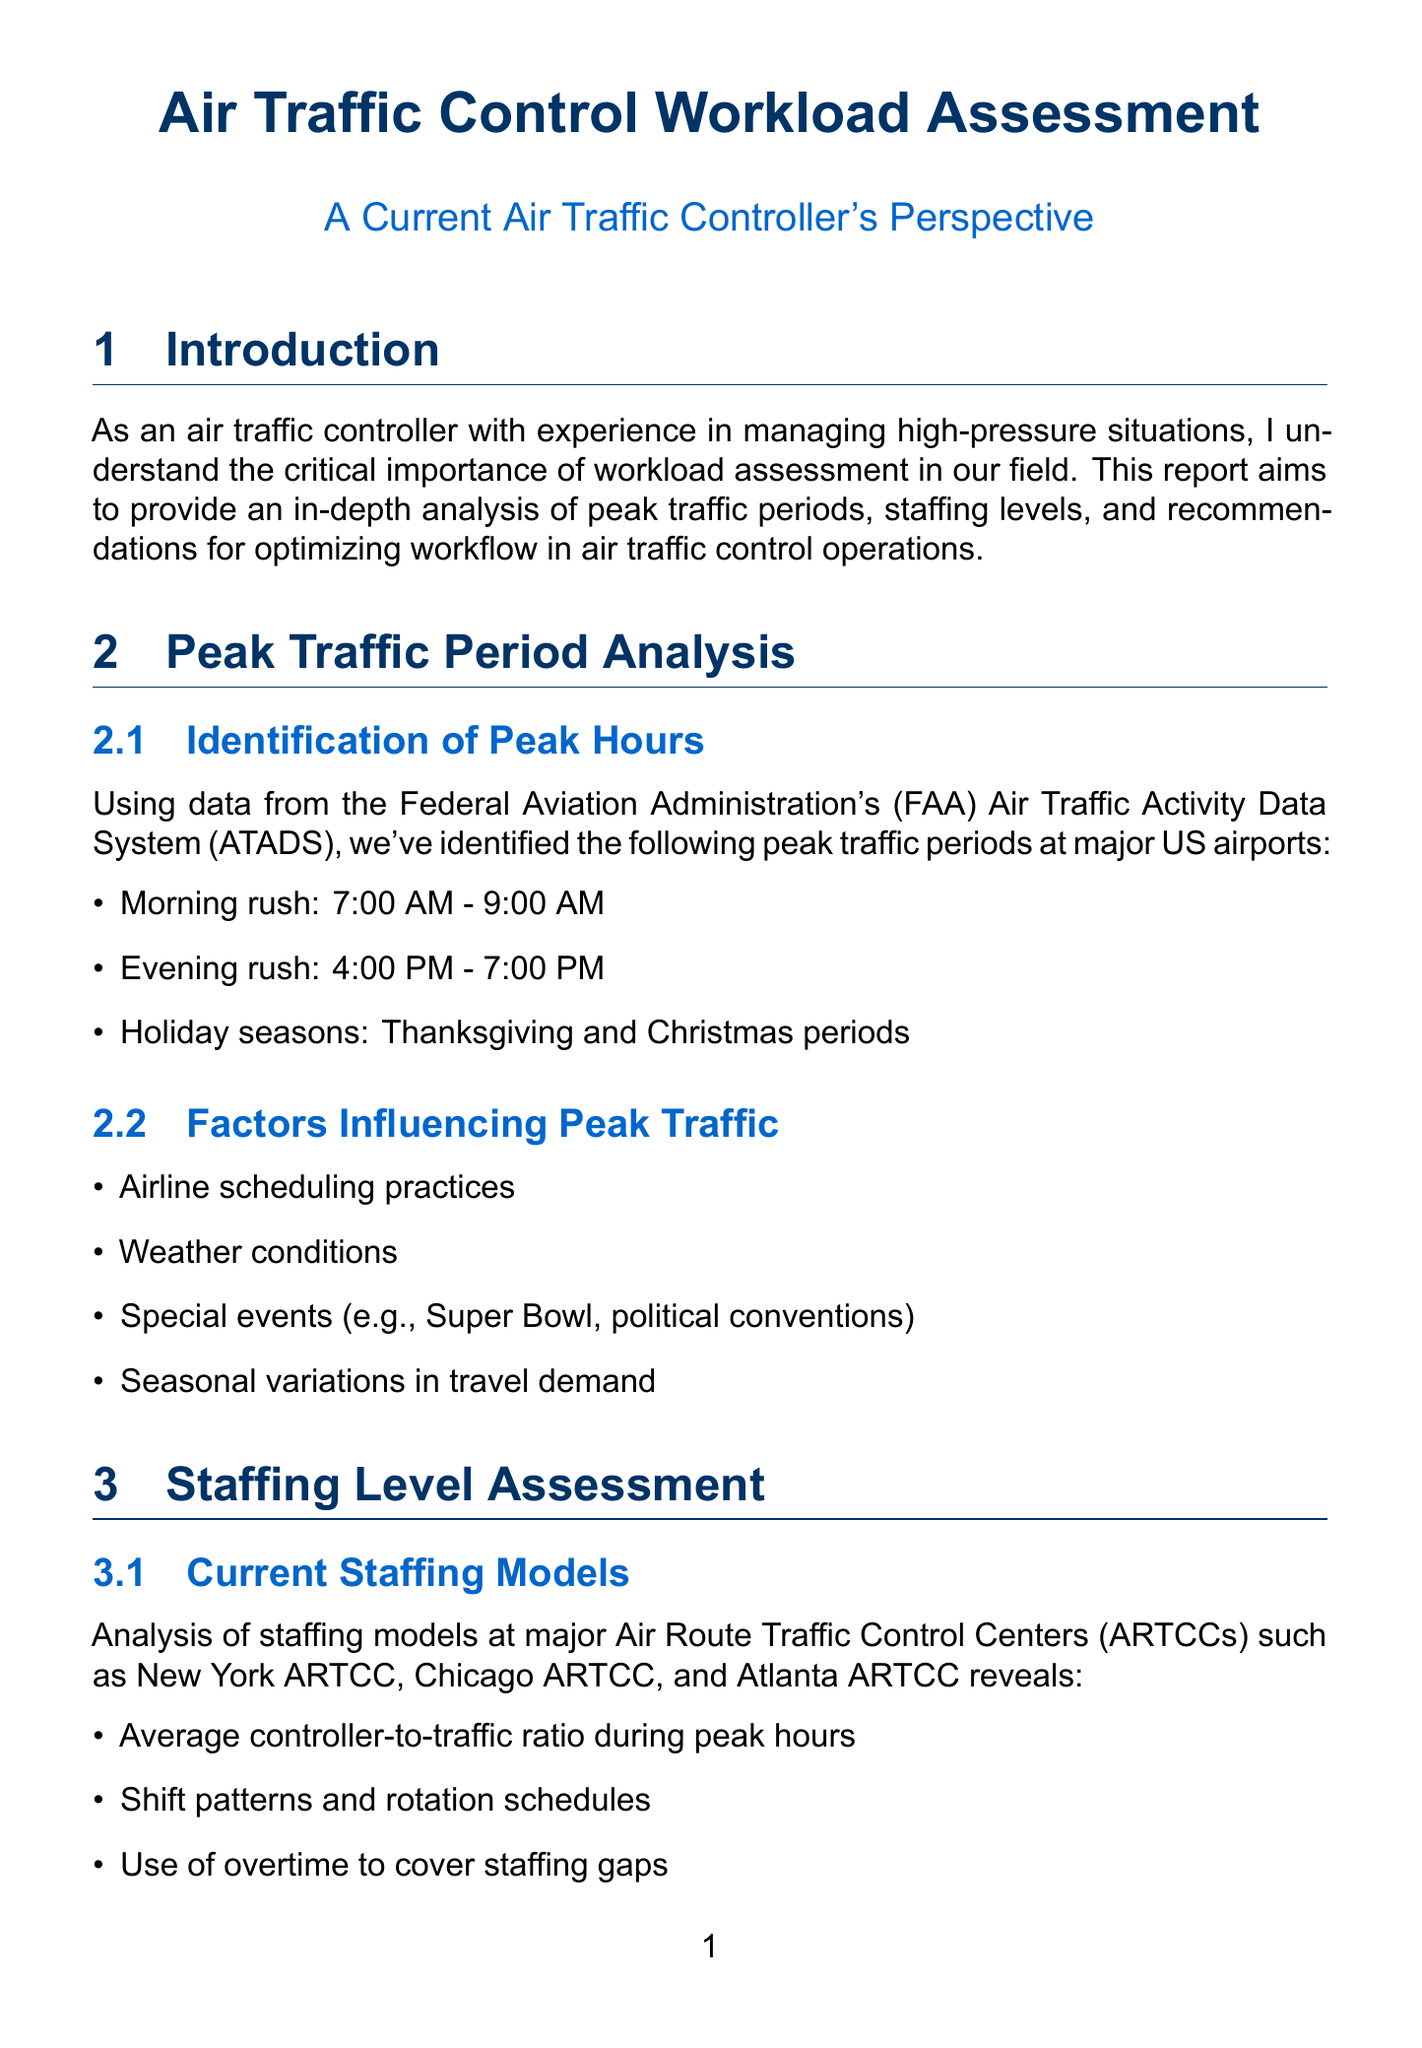What are the identified peak traffic periods? The report specifies peak traffic periods at major US airports as the morning rush from 7:00 AM to 9:00 AM, the evening rush from 4:00 PM to 7:00 PM, and during the Thanksgiving and Christmas holiday seasons.
Answer: Morning rush: 7:00 AM - 9:00 AM, Evening rush: 4:00 PM - 7:00 PM, Holiday seasons: Thanksgiving and Christmas periods What challenges are affecting staffing levels? The document lists three main challenges: a retirement wave of experienced controllers, training pipeline limitations, and budget constraints affecting hiring and training.
Answer: Retirement wave, training pipeline limitations, budget constraints What automation tools are mentioned in the report? The report assesses several current and emerging technologies impacting controller workload, including the Standard Terminal Automation Replacement System (STARS), En Route Automation Modernization (ERAM), ADS-B, and Data Communications (DataComm).
Answer: STARS, ERAM, ADS-B, DataComm Which technique is used for subjective workload assessment? The report mentions specific subjective measures for workload assessment, including the NASA Task Load Index (TLX) and the Subjective Workload Assessment Technique (SWAT).
Answer: NASA Task Load Index (TLX), Subjective Workload Assessment Technique (SWAT) What are the short-term strategies for optimizing workflow? The report outlines short-term strategies such as implementing dynamic sector configurations during peak hours, enhancing break schedules, and utilizing traffic management initiatives more effectively.
Answer: Dynamic sector configurations, enhance break schedules, utilize traffic management initiatives What airport is analyzed as a case study? The report includes case studies for Hartsfield-Jackson Atlanta International Airport (ATL) and the New York ARTCC (ZNY), focusing on how they manage peak traffic periods and staffing challenges.
Answer: Hartsfield-Jackson Atlanta International Airport (ATL) What is emphasized in the conclusion of the report? The conclusion summarizes key findings and highlights the importance of continuous assessment and improvement in air traffic control workload management for ensuring safety and efficiency in congested airspace.
Answer: Continuous assessment and improvement 